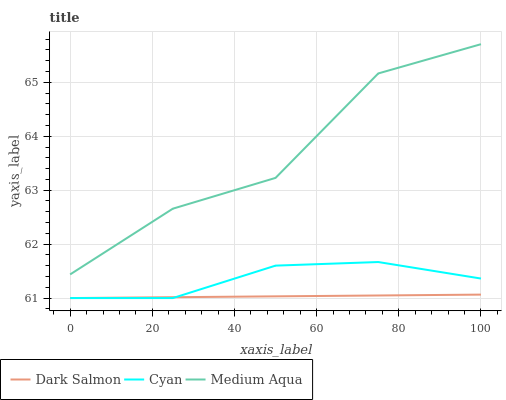Does Dark Salmon have the minimum area under the curve?
Answer yes or no. Yes. Does Medium Aqua have the maximum area under the curve?
Answer yes or no. Yes. Does Medium Aqua have the minimum area under the curve?
Answer yes or no. No. Does Dark Salmon have the maximum area under the curve?
Answer yes or no. No. Is Dark Salmon the smoothest?
Answer yes or no. Yes. Is Medium Aqua the roughest?
Answer yes or no. Yes. Is Medium Aqua the smoothest?
Answer yes or no. No. Is Dark Salmon the roughest?
Answer yes or no. No. Does Cyan have the lowest value?
Answer yes or no. Yes. Does Medium Aqua have the lowest value?
Answer yes or no. No. Does Medium Aqua have the highest value?
Answer yes or no. Yes. Does Dark Salmon have the highest value?
Answer yes or no. No. Is Dark Salmon less than Medium Aqua?
Answer yes or no. Yes. Is Medium Aqua greater than Cyan?
Answer yes or no. Yes. Does Dark Salmon intersect Cyan?
Answer yes or no. Yes. Is Dark Salmon less than Cyan?
Answer yes or no. No. Is Dark Salmon greater than Cyan?
Answer yes or no. No. Does Dark Salmon intersect Medium Aqua?
Answer yes or no. No. 